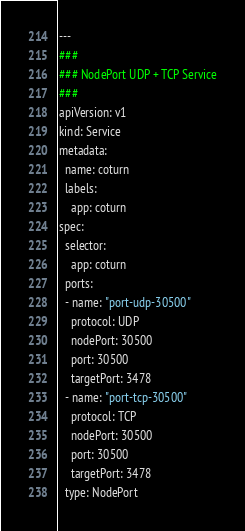<code> <loc_0><loc_0><loc_500><loc_500><_YAML_>---
###
### NodePort UDP + TCP Service
###
apiVersion: v1
kind: Service
metadata:
  name: coturn
  labels:
    app: coturn
spec:
  selector:
    app: coturn
  ports:
  - name: "port-udp-30500"
    protocol: UDP
    nodePort: 30500
    port: 30500
    targetPort: 3478
  - name: "port-tcp-30500"
    protocol: TCP
    nodePort: 30500
    port: 30500
    targetPort: 3478
  type: NodePort

</code> 